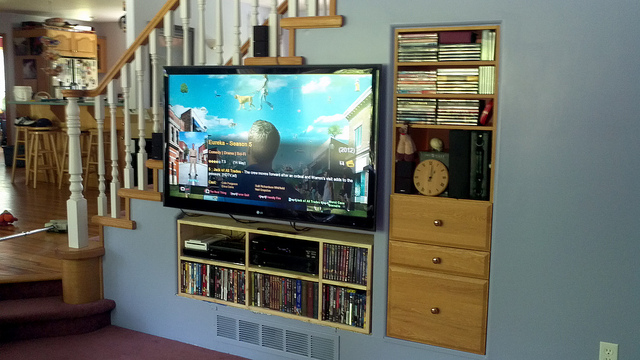<image>What time is shown on the TV? It is unknown what time is shown on the TV. It can be '1:00 pm', '5:00', '2:15', '20:12' or 'noon'. What time is shown on the TV? It is ambiguous what time is shown on the TV. It can be seen '1:00 pm', '1:00', '5:00', '2:15', '0', '20:12' or 'noon'. 